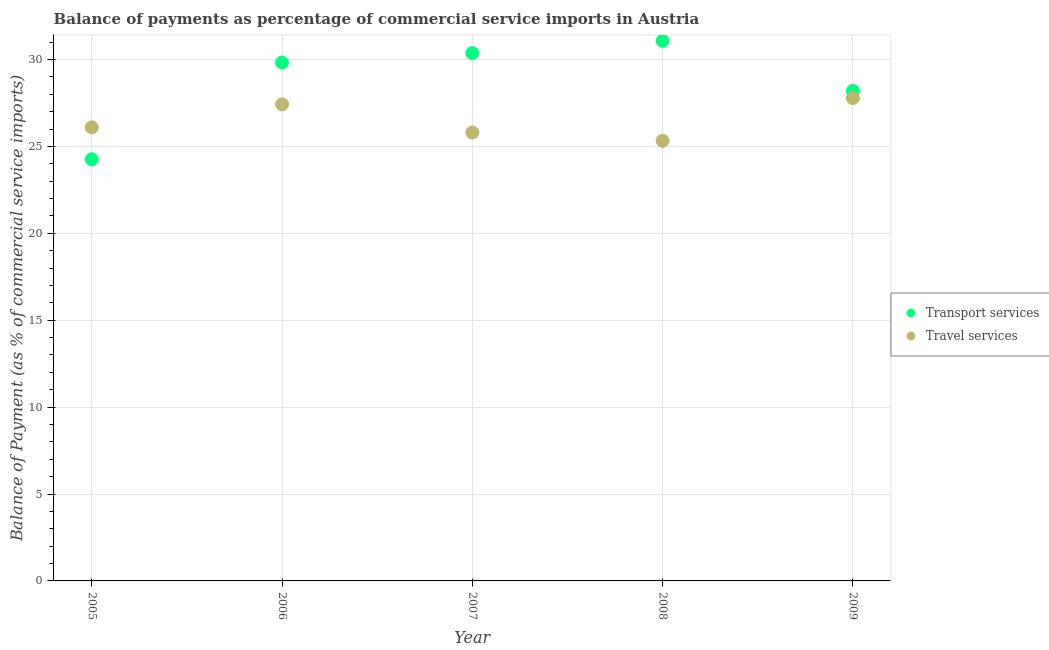What is the balance of payments of travel services in 2005?
Your answer should be very brief. 26.1. Across all years, what is the maximum balance of payments of transport services?
Your answer should be very brief. 31.08. Across all years, what is the minimum balance of payments of travel services?
Ensure brevity in your answer.  25.32. What is the total balance of payments of transport services in the graph?
Your answer should be compact. 143.72. What is the difference between the balance of payments of travel services in 2008 and that in 2009?
Ensure brevity in your answer.  -2.46. What is the difference between the balance of payments of transport services in 2007 and the balance of payments of travel services in 2006?
Ensure brevity in your answer.  2.94. What is the average balance of payments of transport services per year?
Make the answer very short. 28.74. In the year 2008, what is the difference between the balance of payments of travel services and balance of payments of transport services?
Make the answer very short. -5.75. What is the ratio of the balance of payments of transport services in 2006 to that in 2008?
Ensure brevity in your answer.  0.96. What is the difference between the highest and the second highest balance of payments of travel services?
Provide a succinct answer. 0.36. What is the difference between the highest and the lowest balance of payments of transport services?
Ensure brevity in your answer.  6.82. Does the balance of payments of travel services monotonically increase over the years?
Your answer should be very brief. No. Is the balance of payments of transport services strictly greater than the balance of payments of travel services over the years?
Ensure brevity in your answer.  No. Is the balance of payments of travel services strictly less than the balance of payments of transport services over the years?
Ensure brevity in your answer.  No. Are the values on the major ticks of Y-axis written in scientific E-notation?
Keep it short and to the point. No. Does the graph contain any zero values?
Make the answer very short. No. How are the legend labels stacked?
Offer a very short reply. Vertical. What is the title of the graph?
Provide a short and direct response. Balance of payments as percentage of commercial service imports in Austria. What is the label or title of the Y-axis?
Offer a very short reply. Balance of Payment (as % of commercial service imports). What is the Balance of Payment (as % of commercial service imports) of Transport services in 2005?
Offer a very short reply. 24.26. What is the Balance of Payment (as % of commercial service imports) of Travel services in 2005?
Ensure brevity in your answer.  26.1. What is the Balance of Payment (as % of commercial service imports) of Transport services in 2006?
Give a very brief answer. 29.82. What is the Balance of Payment (as % of commercial service imports) of Travel services in 2006?
Your answer should be compact. 27.42. What is the Balance of Payment (as % of commercial service imports) of Transport services in 2007?
Offer a very short reply. 30.37. What is the Balance of Payment (as % of commercial service imports) of Travel services in 2007?
Your response must be concise. 25.8. What is the Balance of Payment (as % of commercial service imports) of Transport services in 2008?
Offer a very short reply. 31.08. What is the Balance of Payment (as % of commercial service imports) of Travel services in 2008?
Ensure brevity in your answer.  25.32. What is the Balance of Payment (as % of commercial service imports) of Transport services in 2009?
Your answer should be compact. 28.19. What is the Balance of Payment (as % of commercial service imports) of Travel services in 2009?
Ensure brevity in your answer.  27.78. Across all years, what is the maximum Balance of Payment (as % of commercial service imports) in Transport services?
Provide a short and direct response. 31.08. Across all years, what is the maximum Balance of Payment (as % of commercial service imports) of Travel services?
Your response must be concise. 27.78. Across all years, what is the minimum Balance of Payment (as % of commercial service imports) in Transport services?
Ensure brevity in your answer.  24.26. Across all years, what is the minimum Balance of Payment (as % of commercial service imports) of Travel services?
Keep it short and to the point. 25.32. What is the total Balance of Payment (as % of commercial service imports) in Transport services in the graph?
Keep it short and to the point. 143.72. What is the total Balance of Payment (as % of commercial service imports) of Travel services in the graph?
Your answer should be very brief. 132.43. What is the difference between the Balance of Payment (as % of commercial service imports) of Transport services in 2005 and that in 2006?
Your answer should be compact. -5.56. What is the difference between the Balance of Payment (as % of commercial service imports) of Travel services in 2005 and that in 2006?
Ensure brevity in your answer.  -1.33. What is the difference between the Balance of Payment (as % of commercial service imports) of Transport services in 2005 and that in 2007?
Provide a succinct answer. -6.11. What is the difference between the Balance of Payment (as % of commercial service imports) of Travel services in 2005 and that in 2007?
Keep it short and to the point. 0.29. What is the difference between the Balance of Payment (as % of commercial service imports) of Transport services in 2005 and that in 2008?
Ensure brevity in your answer.  -6.82. What is the difference between the Balance of Payment (as % of commercial service imports) in Travel services in 2005 and that in 2008?
Ensure brevity in your answer.  0.77. What is the difference between the Balance of Payment (as % of commercial service imports) in Transport services in 2005 and that in 2009?
Provide a succinct answer. -3.93. What is the difference between the Balance of Payment (as % of commercial service imports) of Travel services in 2005 and that in 2009?
Offer a terse response. -1.69. What is the difference between the Balance of Payment (as % of commercial service imports) of Transport services in 2006 and that in 2007?
Your response must be concise. -0.54. What is the difference between the Balance of Payment (as % of commercial service imports) in Travel services in 2006 and that in 2007?
Ensure brevity in your answer.  1.62. What is the difference between the Balance of Payment (as % of commercial service imports) in Transport services in 2006 and that in 2008?
Give a very brief answer. -1.25. What is the difference between the Balance of Payment (as % of commercial service imports) in Travel services in 2006 and that in 2008?
Ensure brevity in your answer.  2.1. What is the difference between the Balance of Payment (as % of commercial service imports) in Transport services in 2006 and that in 2009?
Your answer should be compact. 1.63. What is the difference between the Balance of Payment (as % of commercial service imports) in Travel services in 2006 and that in 2009?
Keep it short and to the point. -0.36. What is the difference between the Balance of Payment (as % of commercial service imports) in Transport services in 2007 and that in 2008?
Your answer should be compact. -0.71. What is the difference between the Balance of Payment (as % of commercial service imports) of Travel services in 2007 and that in 2008?
Keep it short and to the point. 0.48. What is the difference between the Balance of Payment (as % of commercial service imports) of Transport services in 2007 and that in 2009?
Your response must be concise. 2.17. What is the difference between the Balance of Payment (as % of commercial service imports) in Travel services in 2007 and that in 2009?
Offer a terse response. -1.98. What is the difference between the Balance of Payment (as % of commercial service imports) in Transport services in 2008 and that in 2009?
Offer a very short reply. 2.88. What is the difference between the Balance of Payment (as % of commercial service imports) of Travel services in 2008 and that in 2009?
Ensure brevity in your answer.  -2.46. What is the difference between the Balance of Payment (as % of commercial service imports) of Transport services in 2005 and the Balance of Payment (as % of commercial service imports) of Travel services in 2006?
Your response must be concise. -3.16. What is the difference between the Balance of Payment (as % of commercial service imports) in Transport services in 2005 and the Balance of Payment (as % of commercial service imports) in Travel services in 2007?
Make the answer very short. -1.54. What is the difference between the Balance of Payment (as % of commercial service imports) in Transport services in 2005 and the Balance of Payment (as % of commercial service imports) in Travel services in 2008?
Provide a succinct answer. -1.06. What is the difference between the Balance of Payment (as % of commercial service imports) of Transport services in 2005 and the Balance of Payment (as % of commercial service imports) of Travel services in 2009?
Offer a very short reply. -3.52. What is the difference between the Balance of Payment (as % of commercial service imports) in Transport services in 2006 and the Balance of Payment (as % of commercial service imports) in Travel services in 2007?
Your answer should be compact. 4.02. What is the difference between the Balance of Payment (as % of commercial service imports) in Transport services in 2006 and the Balance of Payment (as % of commercial service imports) in Travel services in 2008?
Ensure brevity in your answer.  4.5. What is the difference between the Balance of Payment (as % of commercial service imports) in Transport services in 2006 and the Balance of Payment (as % of commercial service imports) in Travel services in 2009?
Your answer should be very brief. 2.04. What is the difference between the Balance of Payment (as % of commercial service imports) in Transport services in 2007 and the Balance of Payment (as % of commercial service imports) in Travel services in 2008?
Provide a short and direct response. 5.04. What is the difference between the Balance of Payment (as % of commercial service imports) in Transport services in 2007 and the Balance of Payment (as % of commercial service imports) in Travel services in 2009?
Offer a terse response. 2.58. What is the difference between the Balance of Payment (as % of commercial service imports) of Transport services in 2008 and the Balance of Payment (as % of commercial service imports) of Travel services in 2009?
Ensure brevity in your answer.  3.29. What is the average Balance of Payment (as % of commercial service imports) of Transport services per year?
Ensure brevity in your answer.  28.74. What is the average Balance of Payment (as % of commercial service imports) of Travel services per year?
Your answer should be very brief. 26.49. In the year 2005, what is the difference between the Balance of Payment (as % of commercial service imports) in Transport services and Balance of Payment (as % of commercial service imports) in Travel services?
Make the answer very short. -1.84. In the year 2006, what is the difference between the Balance of Payment (as % of commercial service imports) in Transport services and Balance of Payment (as % of commercial service imports) in Travel services?
Provide a short and direct response. 2.4. In the year 2007, what is the difference between the Balance of Payment (as % of commercial service imports) of Transport services and Balance of Payment (as % of commercial service imports) of Travel services?
Offer a terse response. 4.56. In the year 2008, what is the difference between the Balance of Payment (as % of commercial service imports) of Transport services and Balance of Payment (as % of commercial service imports) of Travel services?
Your response must be concise. 5.75. In the year 2009, what is the difference between the Balance of Payment (as % of commercial service imports) of Transport services and Balance of Payment (as % of commercial service imports) of Travel services?
Provide a short and direct response. 0.41. What is the ratio of the Balance of Payment (as % of commercial service imports) in Transport services in 2005 to that in 2006?
Make the answer very short. 0.81. What is the ratio of the Balance of Payment (as % of commercial service imports) of Travel services in 2005 to that in 2006?
Ensure brevity in your answer.  0.95. What is the ratio of the Balance of Payment (as % of commercial service imports) in Transport services in 2005 to that in 2007?
Provide a short and direct response. 0.8. What is the ratio of the Balance of Payment (as % of commercial service imports) of Travel services in 2005 to that in 2007?
Offer a terse response. 1.01. What is the ratio of the Balance of Payment (as % of commercial service imports) of Transport services in 2005 to that in 2008?
Offer a terse response. 0.78. What is the ratio of the Balance of Payment (as % of commercial service imports) of Travel services in 2005 to that in 2008?
Offer a very short reply. 1.03. What is the ratio of the Balance of Payment (as % of commercial service imports) of Transport services in 2005 to that in 2009?
Make the answer very short. 0.86. What is the ratio of the Balance of Payment (as % of commercial service imports) in Travel services in 2005 to that in 2009?
Make the answer very short. 0.94. What is the ratio of the Balance of Payment (as % of commercial service imports) in Transport services in 2006 to that in 2007?
Offer a terse response. 0.98. What is the ratio of the Balance of Payment (as % of commercial service imports) in Travel services in 2006 to that in 2007?
Your answer should be very brief. 1.06. What is the ratio of the Balance of Payment (as % of commercial service imports) of Transport services in 2006 to that in 2008?
Offer a terse response. 0.96. What is the ratio of the Balance of Payment (as % of commercial service imports) in Travel services in 2006 to that in 2008?
Keep it short and to the point. 1.08. What is the ratio of the Balance of Payment (as % of commercial service imports) in Transport services in 2006 to that in 2009?
Offer a terse response. 1.06. What is the ratio of the Balance of Payment (as % of commercial service imports) in Travel services in 2006 to that in 2009?
Your answer should be very brief. 0.99. What is the ratio of the Balance of Payment (as % of commercial service imports) in Transport services in 2007 to that in 2008?
Offer a terse response. 0.98. What is the ratio of the Balance of Payment (as % of commercial service imports) of Transport services in 2007 to that in 2009?
Provide a short and direct response. 1.08. What is the ratio of the Balance of Payment (as % of commercial service imports) in Travel services in 2007 to that in 2009?
Provide a short and direct response. 0.93. What is the ratio of the Balance of Payment (as % of commercial service imports) of Transport services in 2008 to that in 2009?
Make the answer very short. 1.1. What is the ratio of the Balance of Payment (as % of commercial service imports) in Travel services in 2008 to that in 2009?
Offer a terse response. 0.91. What is the difference between the highest and the second highest Balance of Payment (as % of commercial service imports) in Transport services?
Your answer should be compact. 0.71. What is the difference between the highest and the second highest Balance of Payment (as % of commercial service imports) of Travel services?
Offer a very short reply. 0.36. What is the difference between the highest and the lowest Balance of Payment (as % of commercial service imports) in Transport services?
Your response must be concise. 6.82. What is the difference between the highest and the lowest Balance of Payment (as % of commercial service imports) of Travel services?
Keep it short and to the point. 2.46. 